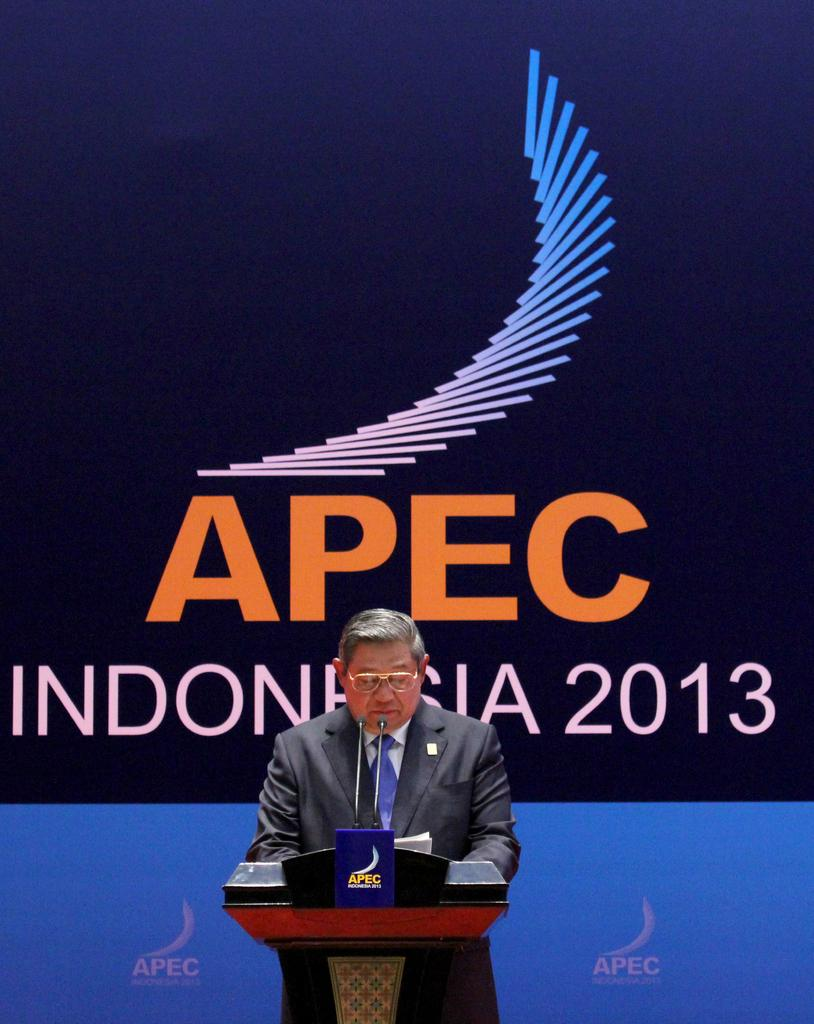<image>
Provide a brief description of the given image. a man standing in front of a huge sign that says 'apec indonesia 2013' on it 